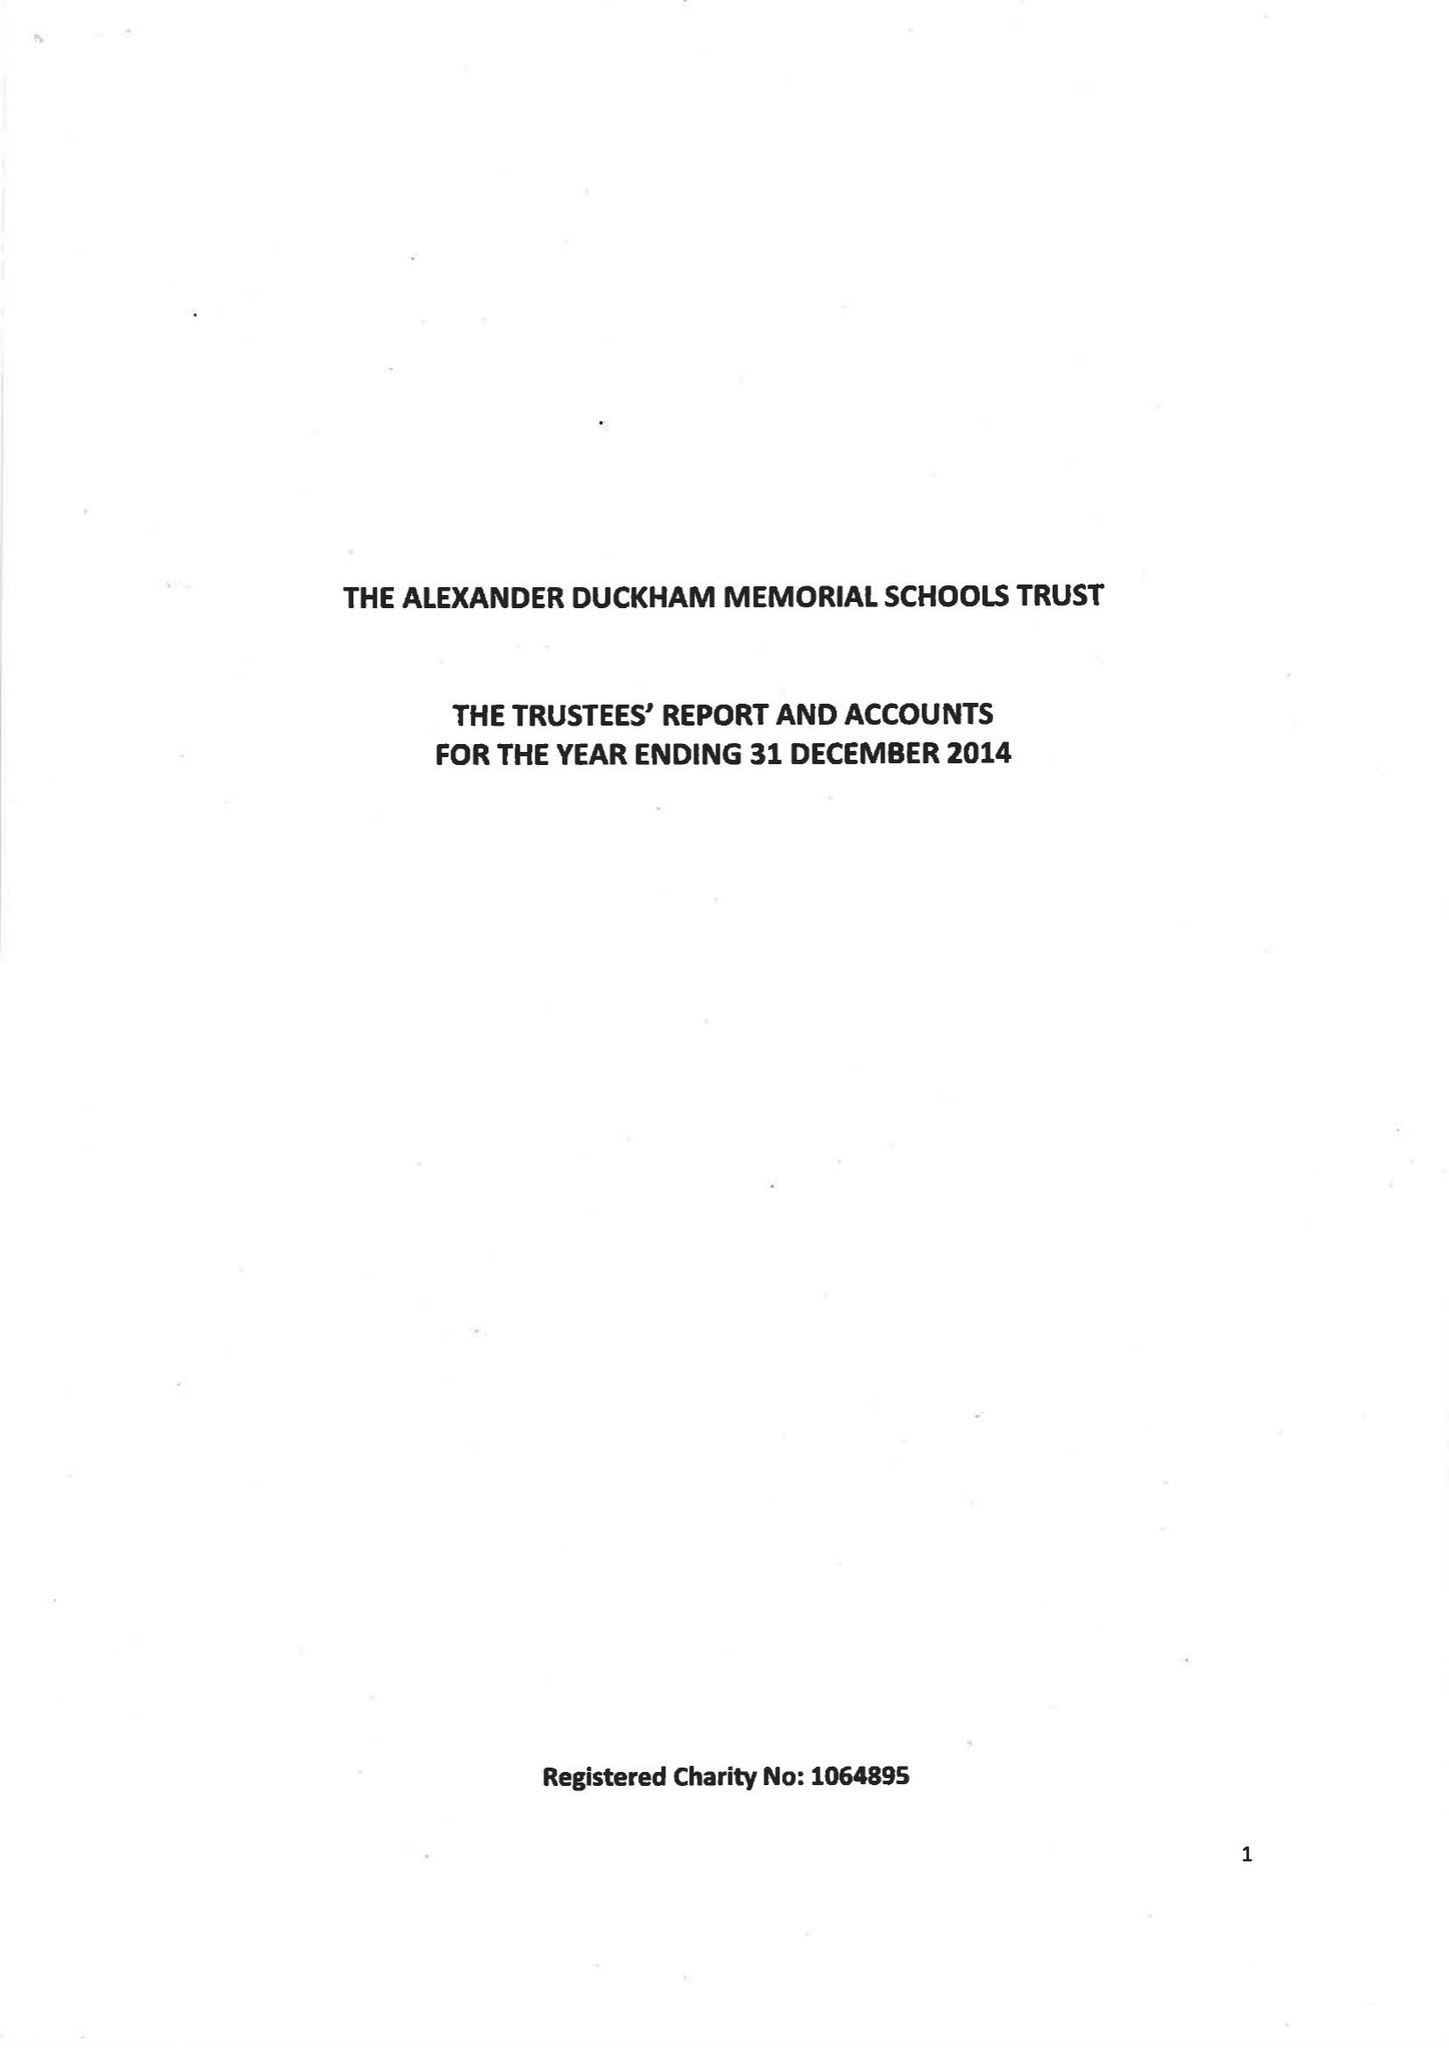What is the value for the address__postcode?
Answer the question using a single word or phrase. SW15 6RU 